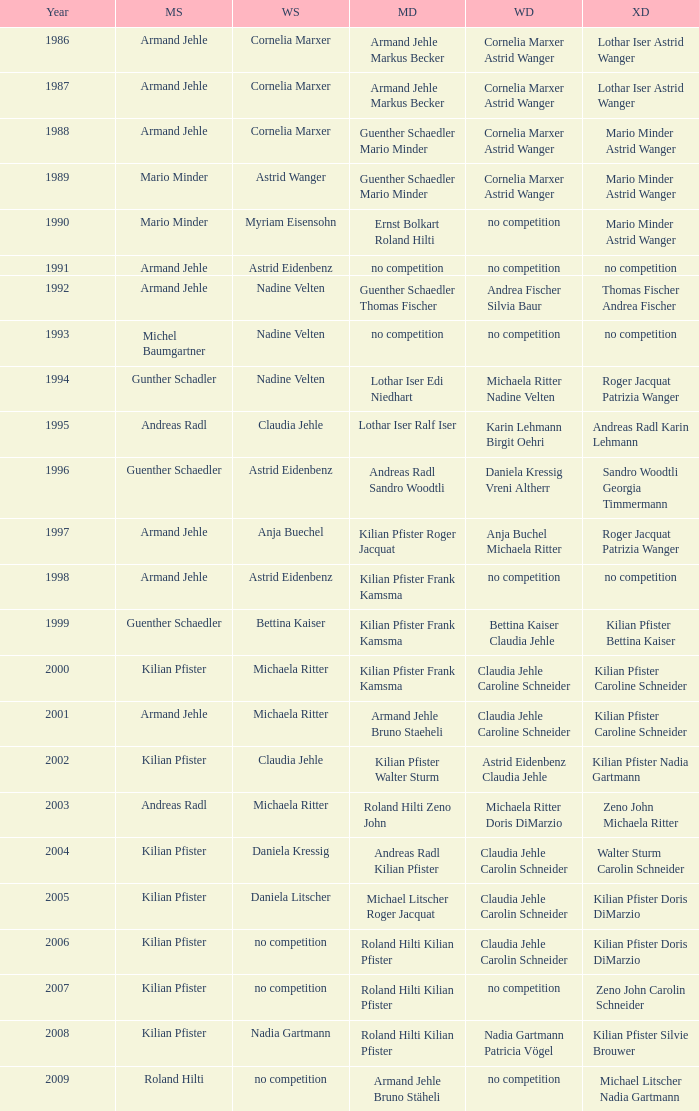In 1987 who was the mens singles Armand Jehle. 